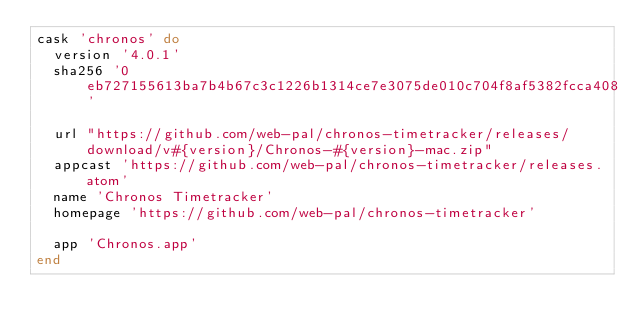Convert code to text. <code><loc_0><loc_0><loc_500><loc_500><_Ruby_>cask 'chronos' do
  version '4.0.1'
  sha256 '0eb727155613ba7b4b67c3c1226b1314ce7e3075de010c704f8af5382fcca408'

  url "https://github.com/web-pal/chronos-timetracker/releases/download/v#{version}/Chronos-#{version}-mac.zip"
  appcast 'https://github.com/web-pal/chronos-timetracker/releases.atom'
  name 'Chronos Timetracker'
  homepage 'https://github.com/web-pal/chronos-timetracker'

  app 'Chronos.app'
end
</code> 